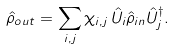Convert formula to latex. <formula><loc_0><loc_0><loc_500><loc_500>\hat { \rho } _ { o u t } = \sum _ { i , j } \chi _ { i , j } \, \hat { U } _ { i } \hat { \rho } _ { i n } \hat { U } _ { j } ^ { \dagger } .</formula> 